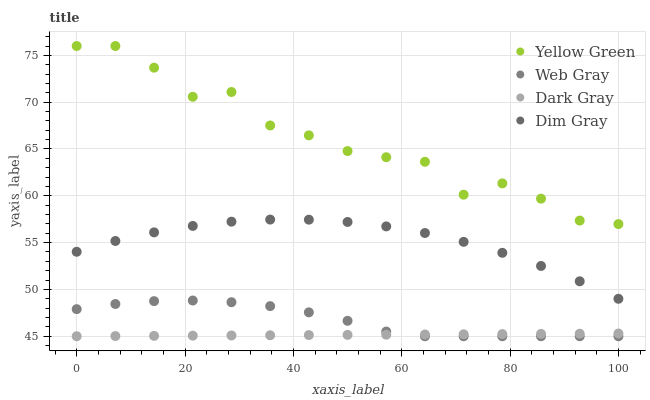Does Dark Gray have the minimum area under the curve?
Answer yes or no. Yes. Does Yellow Green have the maximum area under the curve?
Answer yes or no. Yes. Does Dim Gray have the minimum area under the curve?
Answer yes or no. No. Does Dim Gray have the maximum area under the curve?
Answer yes or no. No. Is Dark Gray the smoothest?
Answer yes or no. Yes. Is Yellow Green the roughest?
Answer yes or no. Yes. Is Dim Gray the smoothest?
Answer yes or no. No. Is Dim Gray the roughest?
Answer yes or no. No. Does Dark Gray have the lowest value?
Answer yes or no. Yes. Does Dim Gray have the lowest value?
Answer yes or no. No. Does Yellow Green have the highest value?
Answer yes or no. Yes. Does Dim Gray have the highest value?
Answer yes or no. No. Is Dim Gray less than Yellow Green?
Answer yes or no. Yes. Is Yellow Green greater than Dark Gray?
Answer yes or no. Yes. Does Web Gray intersect Dark Gray?
Answer yes or no. Yes. Is Web Gray less than Dark Gray?
Answer yes or no. No. Is Web Gray greater than Dark Gray?
Answer yes or no. No. Does Dim Gray intersect Yellow Green?
Answer yes or no. No. 